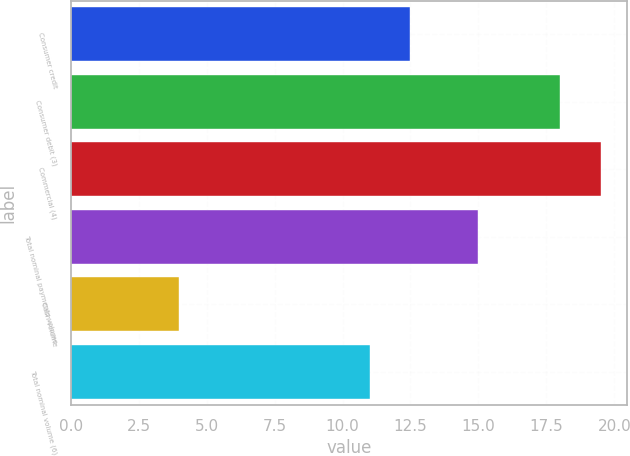<chart> <loc_0><loc_0><loc_500><loc_500><bar_chart><fcel>Consumer credit<fcel>Consumer debit (3)<fcel>Commercial (4)<fcel>Total nominal payments volume<fcel>Cash volume<fcel>Total nominal volume (6)<nl><fcel>12.5<fcel>18<fcel>19.5<fcel>15<fcel>4<fcel>11<nl></chart> 